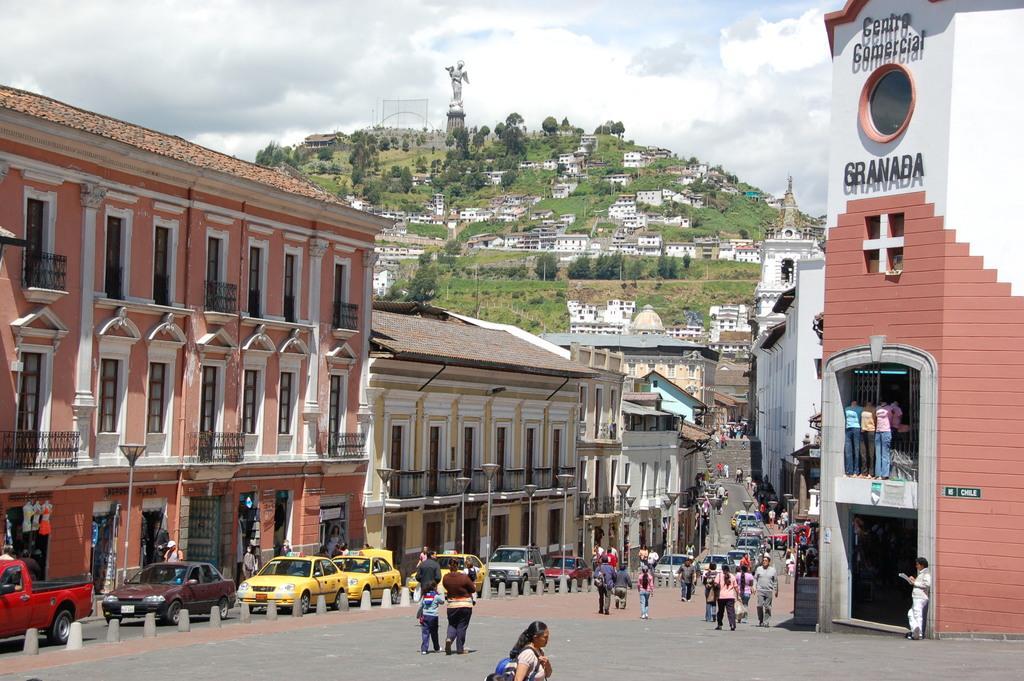In one or two sentences, can you explain what this image depicts? This picture is clicked outside. In the center we can see the group of persons and group of cars. On the right we can see the mannequins wearing dresses and we can see the text on the building. In the background we can see the sky, hills, trees, houses, sculpture of some object and we can see the buildings, lamppost and many other objects, we can see the windows and railings of the buildings. 